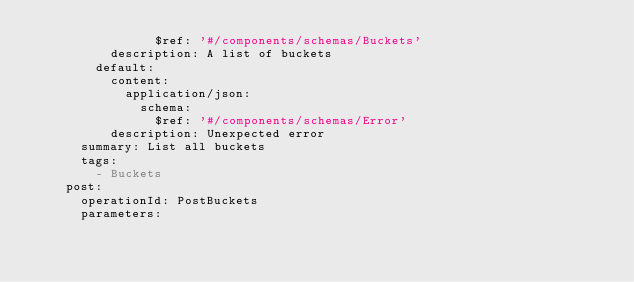<code> <loc_0><loc_0><loc_500><loc_500><_YAML_>                $ref: '#/components/schemas/Buckets'
          description: A list of buckets
        default:
          content:
            application/json:
              schema:
                $ref: '#/components/schemas/Error'
          description: Unexpected error
      summary: List all buckets
      tags:
        - Buckets
    post:
      operationId: PostBuckets
      parameters:</code> 